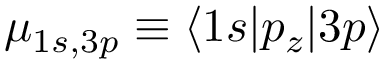<formula> <loc_0><loc_0><loc_500><loc_500>\mu _ { 1 s , 3 p } \equiv \langle 1 s | p _ { z } | 3 p \rangle</formula> 